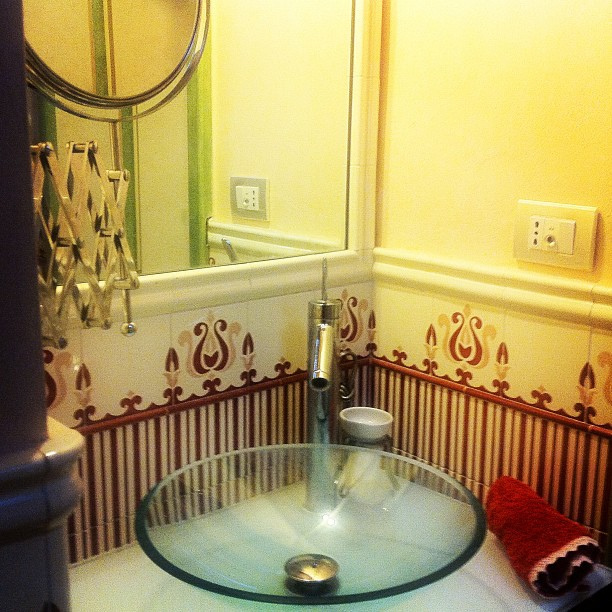<image>Is anyone in the bathroom? I am not sure if anyone is in the bathroom. Is anyone in the bathroom? I don't know if anyone is in the bathroom. It seems like there is no one in the bathroom, but I am not completely sure. 